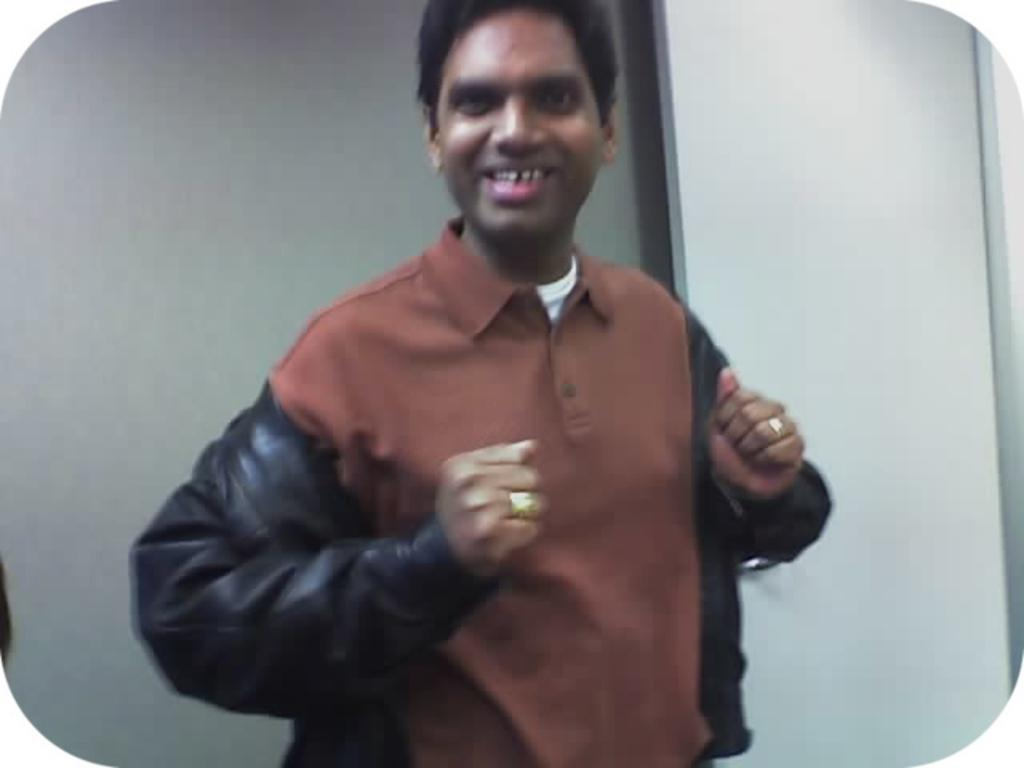Who is the main subject in the image? There is a man in the center of the image. What is the man doing in the image? The man is standing and smiling. What can be seen in the background of the image? There is a wall in the background of the image. What type of grape is the man holding in the image? There is no grape present in the image; the man is not holding any object. 